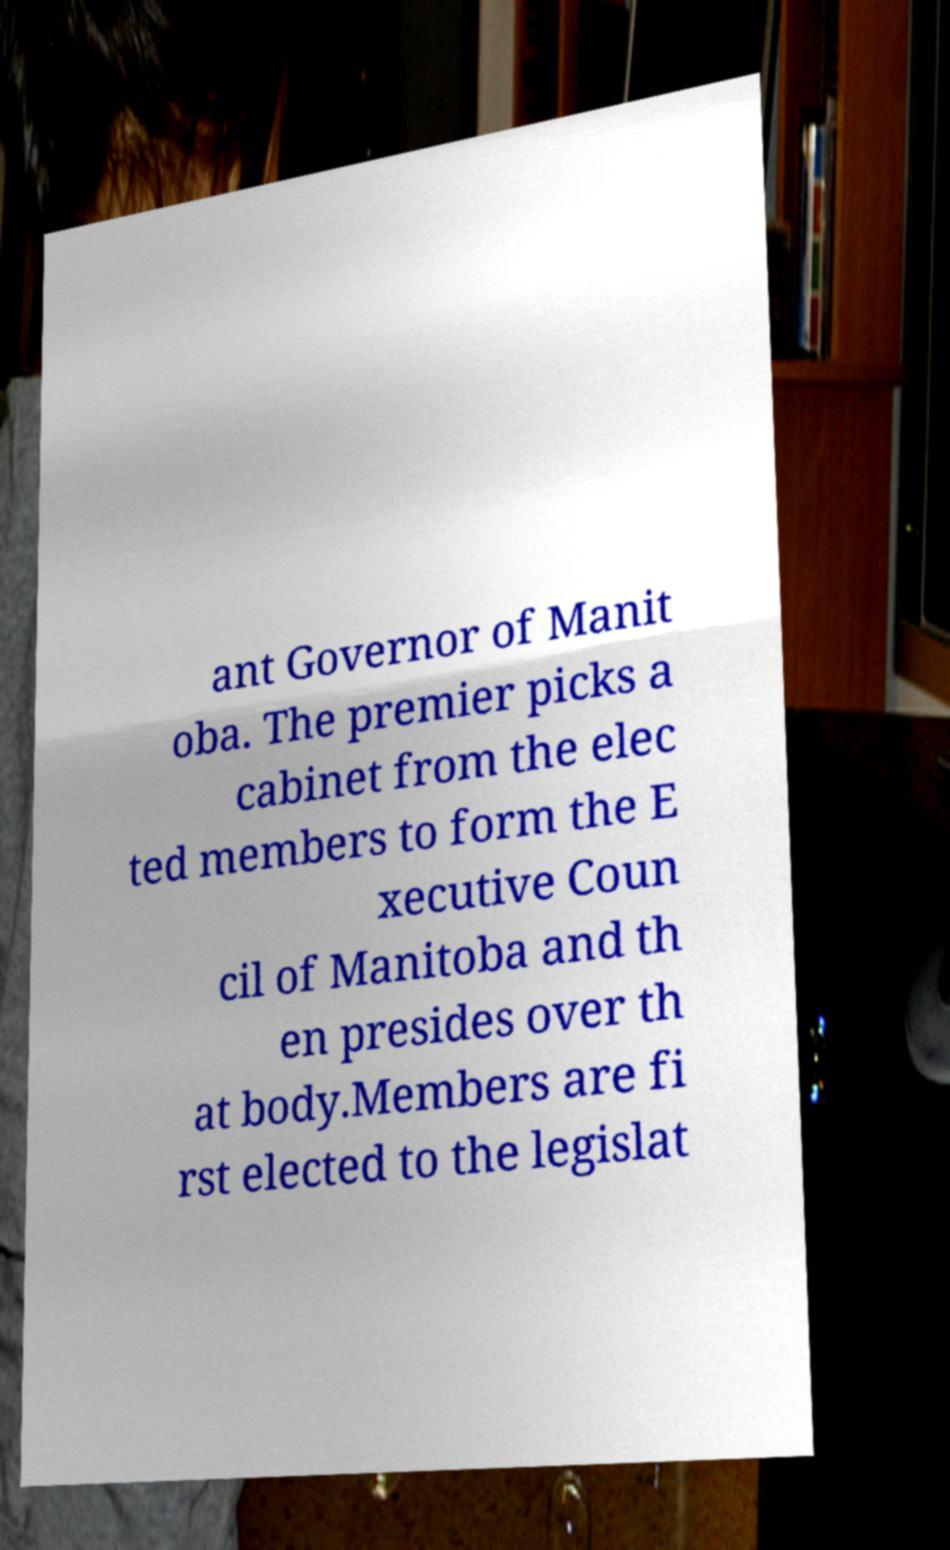What messages or text are displayed in this image? I need them in a readable, typed format. ant Governor of Manit oba. The premier picks a cabinet from the elec ted members to form the E xecutive Coun cil of Manitoba and th en presides over th at body.Members are fi rst elected to the legislat 